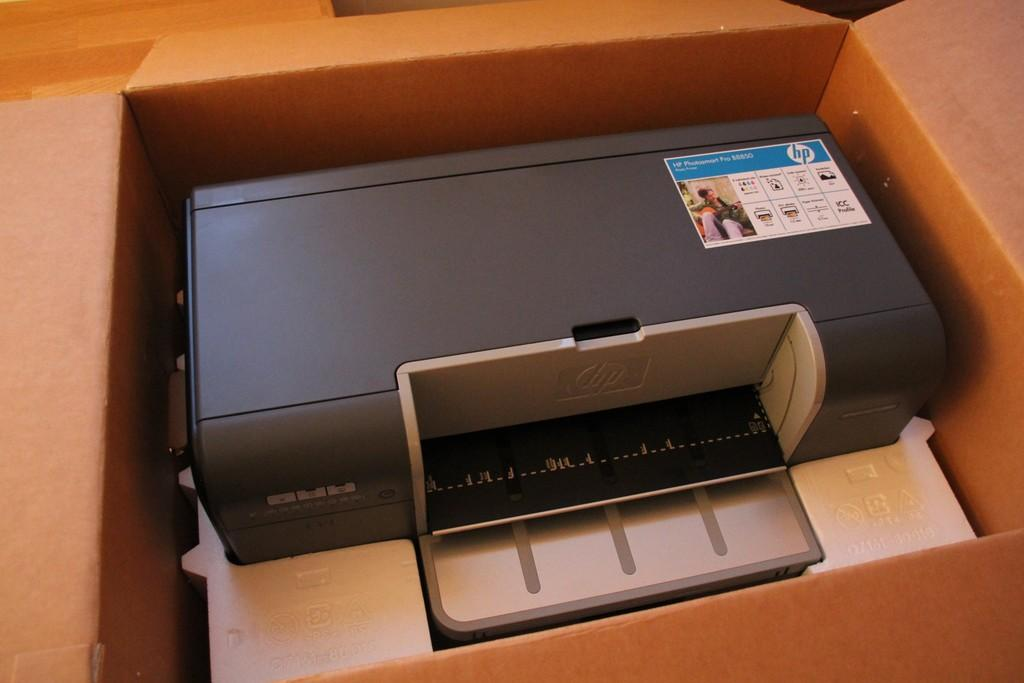<image>
Write a terse but informative summary of the picture. An HP printer is in a cardboard box. 